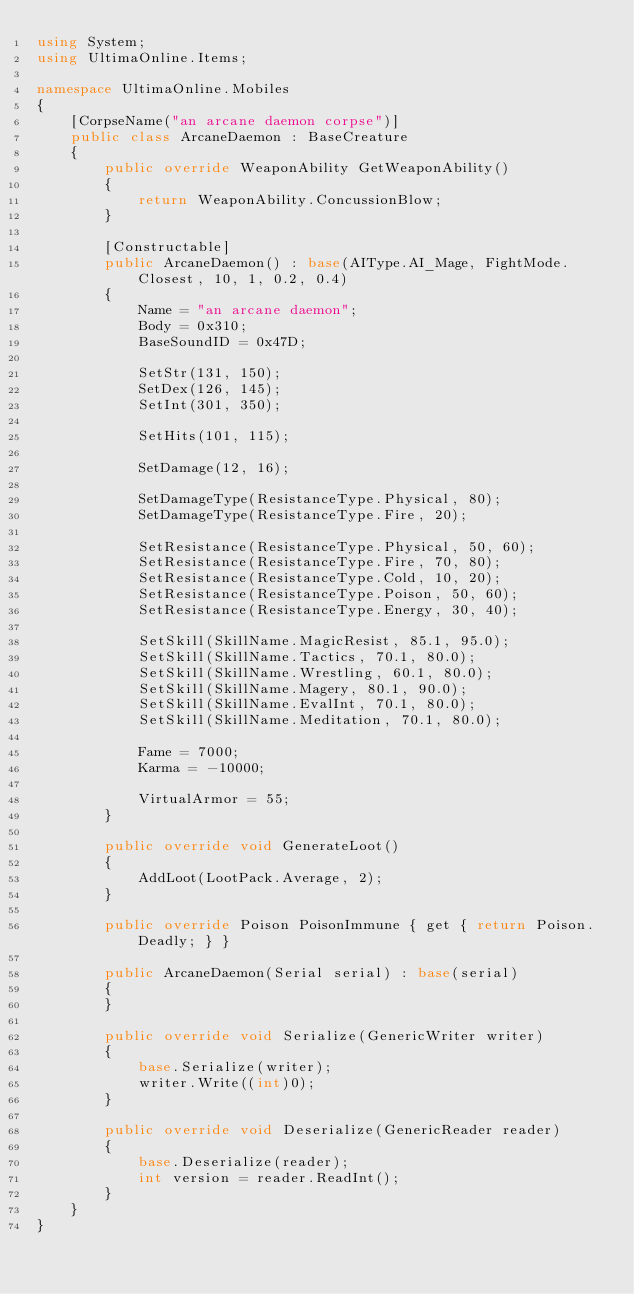Convert code to text. <code><loc_0><loc_0><loc_500><loc_500><_C#_>using System;
using UltimaOnline.Items;

namespace UltimaOnline.Mobiles
{
    [CorpseName("an arcane daemon corpse")]
    public class ArcaneDaemon : BaseCreature
    {
        public override WeaponAbility GetWeaponAbility()
        {
            return WeaponAbility.ConcussionBlow;
        }

        [Constructable]
        public ArcaneDaemon() : base(AIType.AI_Mage, FightMode.Closest, 10, 1, 0.2, 0.4)
        {
            Name = "an arcane daemon";
            Body = 0x310;
            BaseSoundID = 0x47D;

            SetStr(131, 150);
            SetDex(126, 145);
            SetInt(301, 350);

            SetHits(101, 115);

            SetDamage(12, 16);

            SetDamageType(ResistanceType.Physical, 80);
            SetDamageType(ResistanceType.Fire, 20);

            SetResistance(ResistanceType.Physical, 50, 60);
            SetResistance(ResistanceType.Fire, 70, 80);
            SetResistance(ResistanceType.Cold, 10, 20);
            SetResistance(ResistanceType.Poison, 50, 60);
            SetResistance(ResistanceType.Energy, 30, 40);

            SetSkill(SkillName.MagicResist, 85.1, 95.0);
            SetSkill(SkillName.Tactics, 70.1, 80.0);
            SetSkill(SkillName.Wrestling, 60.1, 80.0);
            SetSkill(SkillName.Magery, 80.1, 90.0);
            SetSkill(SkillName.EvalInt, 70.1, 80.0);
            SetSkill(SkillName.Meditation, 70.1, 80.0);

            Fame = 7000;
            Karma = -10000;

            VirtualArmor = 55;
        }

        public override void GenerateLoot()
        {
            AddLoot(LootPack.Average, 2);
        }

        public override Poison PoisonImmune { get { return Poison.Deadly; } }

        public ArcaneDaemon(Serial serial) : base(serial)
        {
        }

        public override void Serialize(GenericWriter writer)
        {
            base.Serialize(writer);
            writer.Write((int)0);
        }

        public override void Deserialize(GenericReader reader)
        {
            base.Deserialize(reader);
            int version = reader.ReadInt();
        }
    }
}</code> 